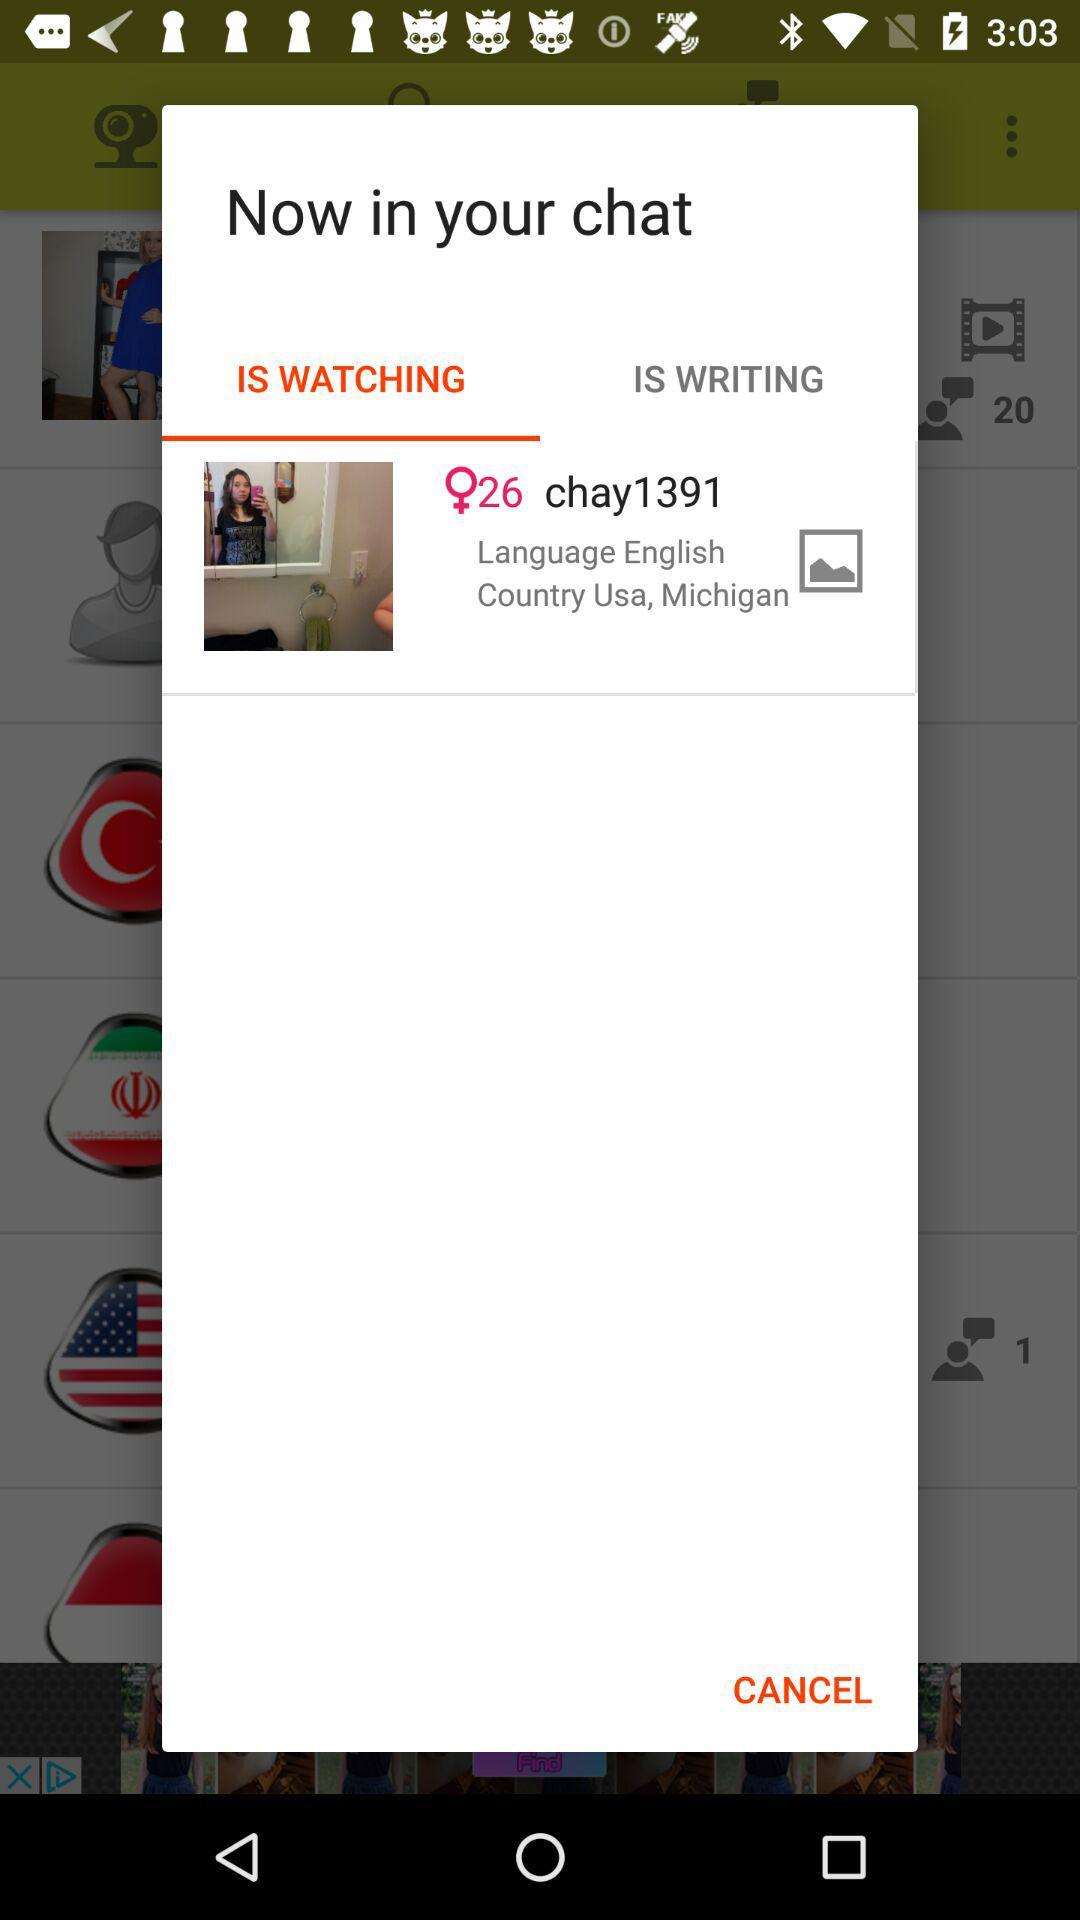What is the country? The country is the United States of America. 